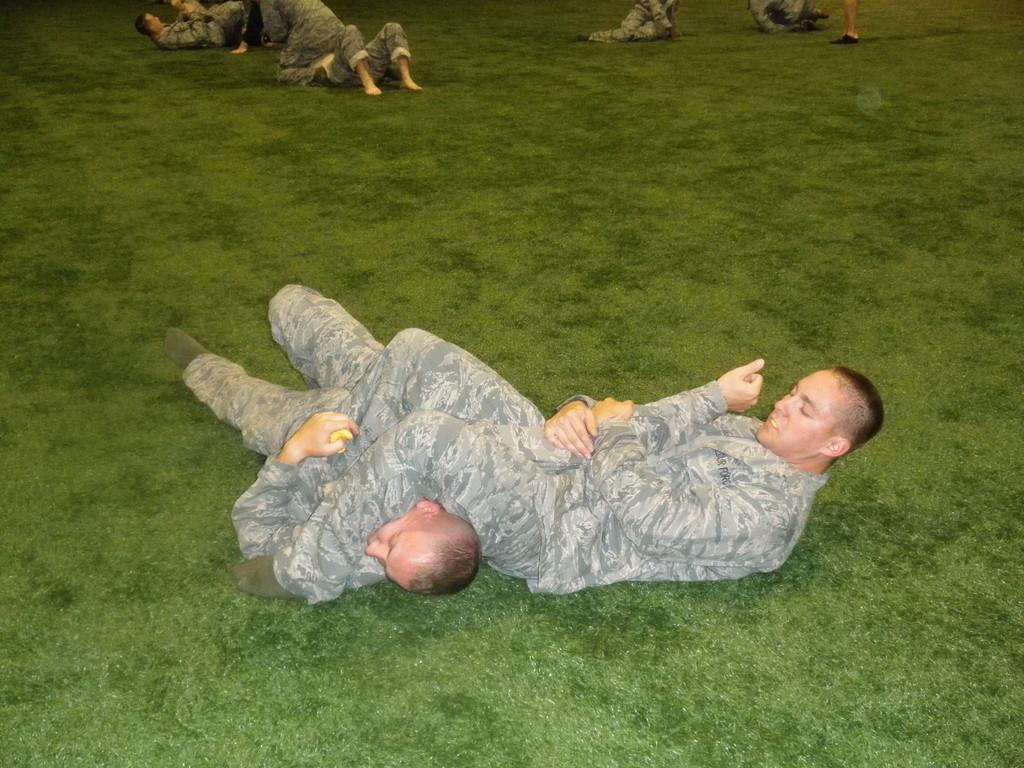How many people are in the image? There is a group of people in the image. What are some of the people in the image doing? Some people are laying on the grass. What type of magic trick is being performed by the people in the image? There is no indication of a magic trick being performed in the image; people are simply laying on the grass. Can you tell me how many basketballs are visible in the image? There is no mention of basketballs in the image; it only shows a group of people laying on the grass. 